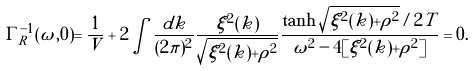<formula> <loc_0><loc_0><loc_500><loc_500>\Gamma ^ { - 1 } _ { R } ( \omega , 0 ) = \frac { 1 } { V } + 2 \int \frac { d k } { ( 2 \pi ) ^ { 2 } } \frac { \xi ^ { 2 } ( k ) } { \sqrt { \xi ^ { 2 } ( k ) + \rho ^ { 2 } } } \frac { \tanh \sqrt { \xi ^ { 2 } ( k ) + \rho ^ { 2 } } / 2 T } { \omega ^ { 2 } - 4 [ \xi ^ { 2 } ( k ) + \rho ^ { 2 } ] } = 0 .</formula> 